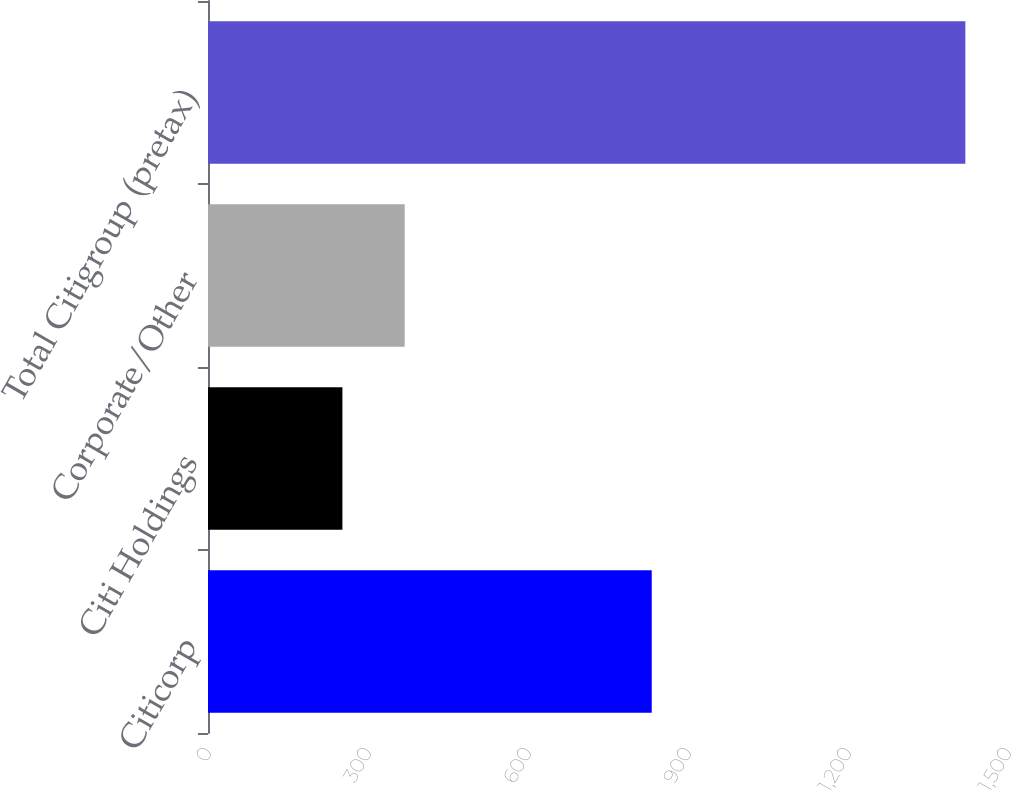Convert chart to OTSL. <chart><loc_0><loc_0><loc_500><loc_500><bar_chart><fcel>Citicorp<fcel>Citi Holdings<fcel>Corporate/Other<fcel>Total Citigroup (pretax)<nl><fcel>832<fcel>252<fcel>368.8<fcel>1420<nl></chart> 